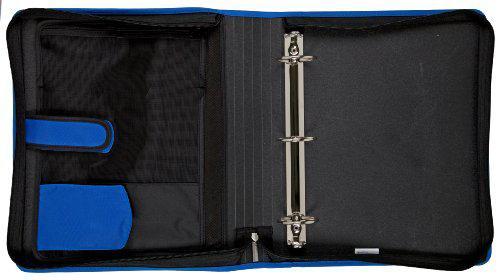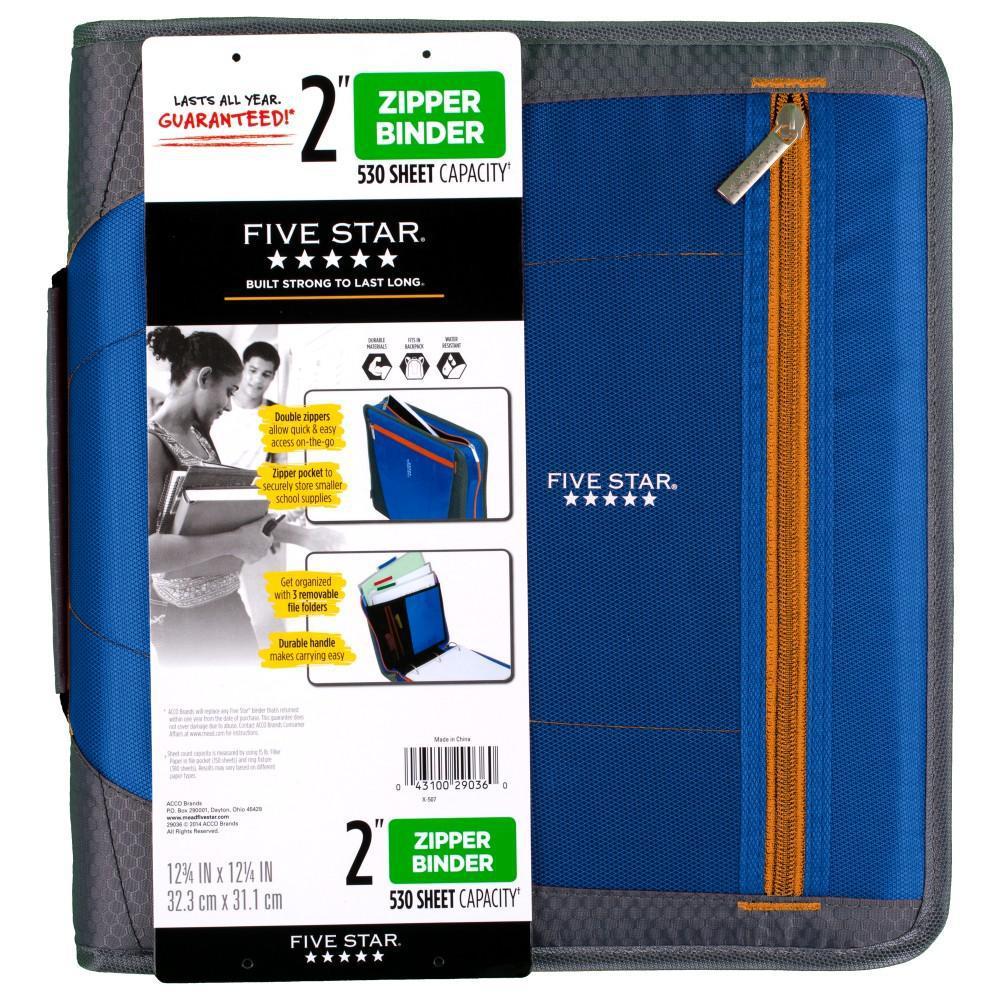The first image is the image on the left, the second image is the image on the right. Analyze the images presented: Is the assertion "The open trapper keeper is filled with paper and other items" valid? Answer yes or no. No. The first image is the image on the left, the second image is the image on the right. Considering the images on both sides, is "The open notebooks contain multiple items; they are not empty." valid? Answer yes or no. No. 